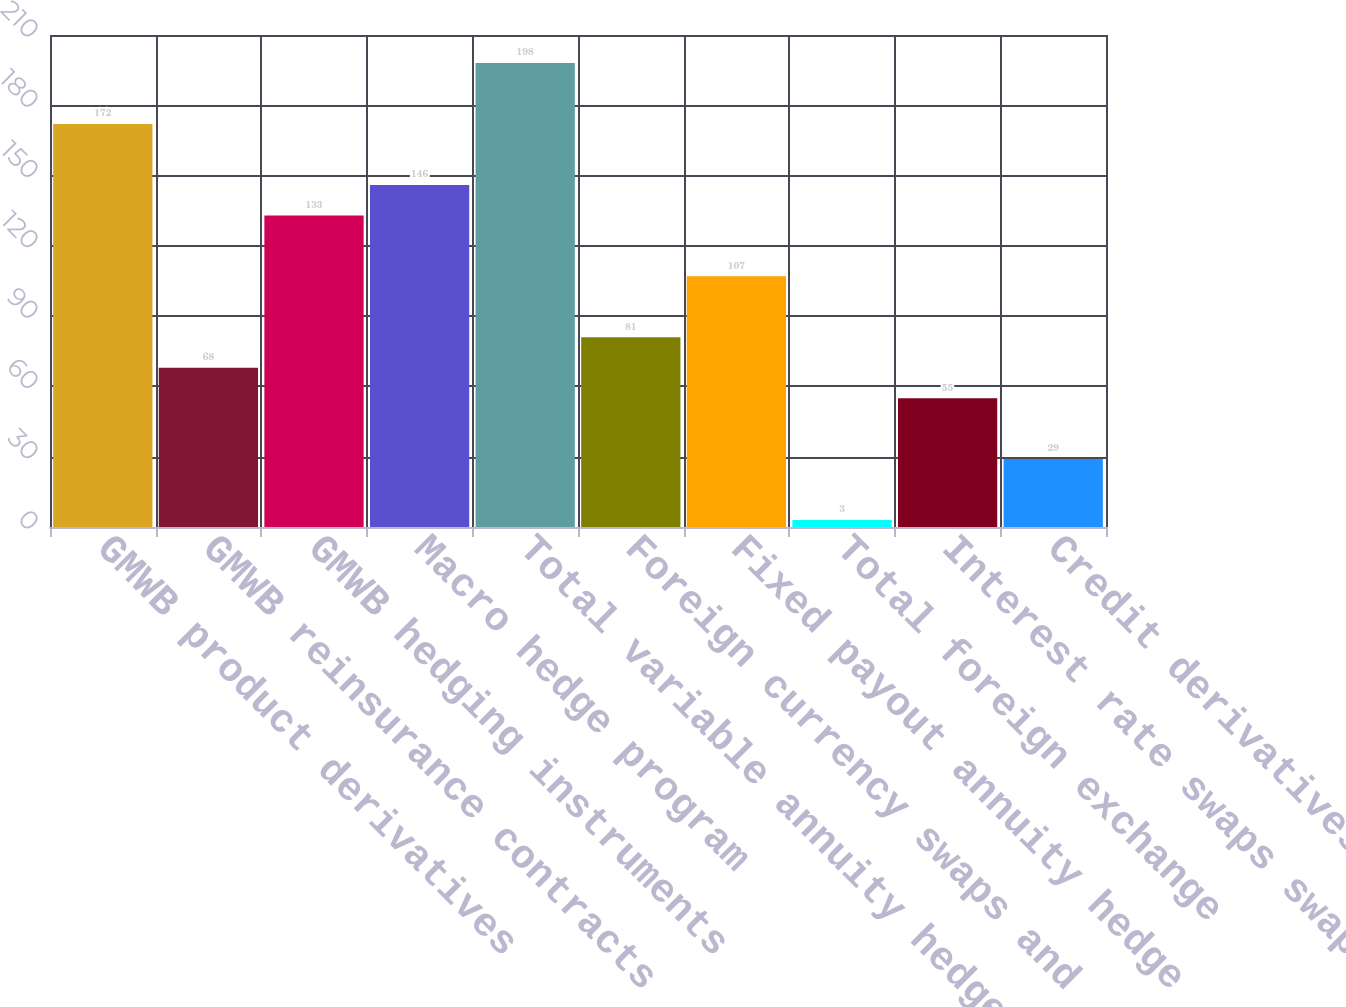<chart> <loc_0><loc_0><loc_500><loc_500><bar_chart><fcel>GMWB product derivatives<fcel>GMWB reinsurance contracts<fcel>GMWB hedging instruments<fcel>Macro hedge program<fcel>Total variable annuity hedge<fcel>Foreign currency swaps and<fcel>Fixed payout annuity hedge<fcel>Total foreign exchange<fcel>Interest rate swaps swaptions<fcel>Credit derivatives that<nl><fcel>172<fcel>68<fcel>133<fcel>146<fcel>198<fcel>81<fcel>107<fcel>3<fcel>55<fcel>29<nl></chart> 